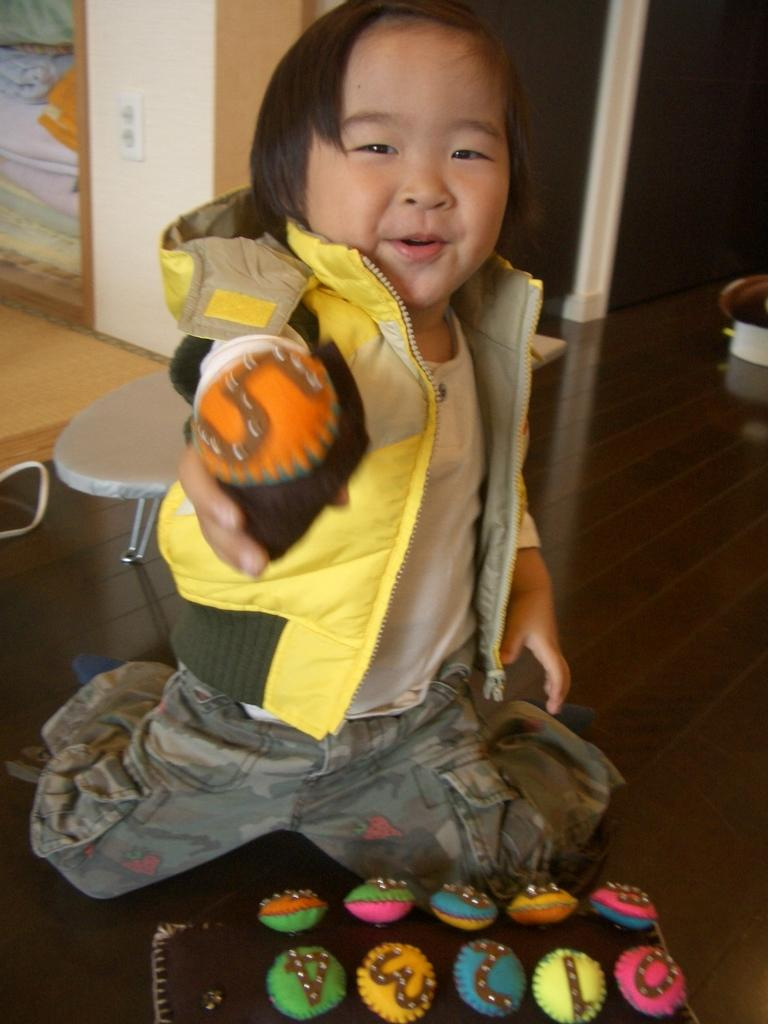What is the main subject of the image? The main subject of the image is a kid. What is the kid holding in the image? The kid is holding a toy. Are there any other toys visible in the image? Yes, there are additional toys in front of the kid. What can be seen in the background of the image? There is a chair in the background of the image. What type of pencil can be seen in the image? There is no pencil present in the image. What is the ground like in the image? The ground is not visible in the image; it only shows the kid, toys, and the chair. 